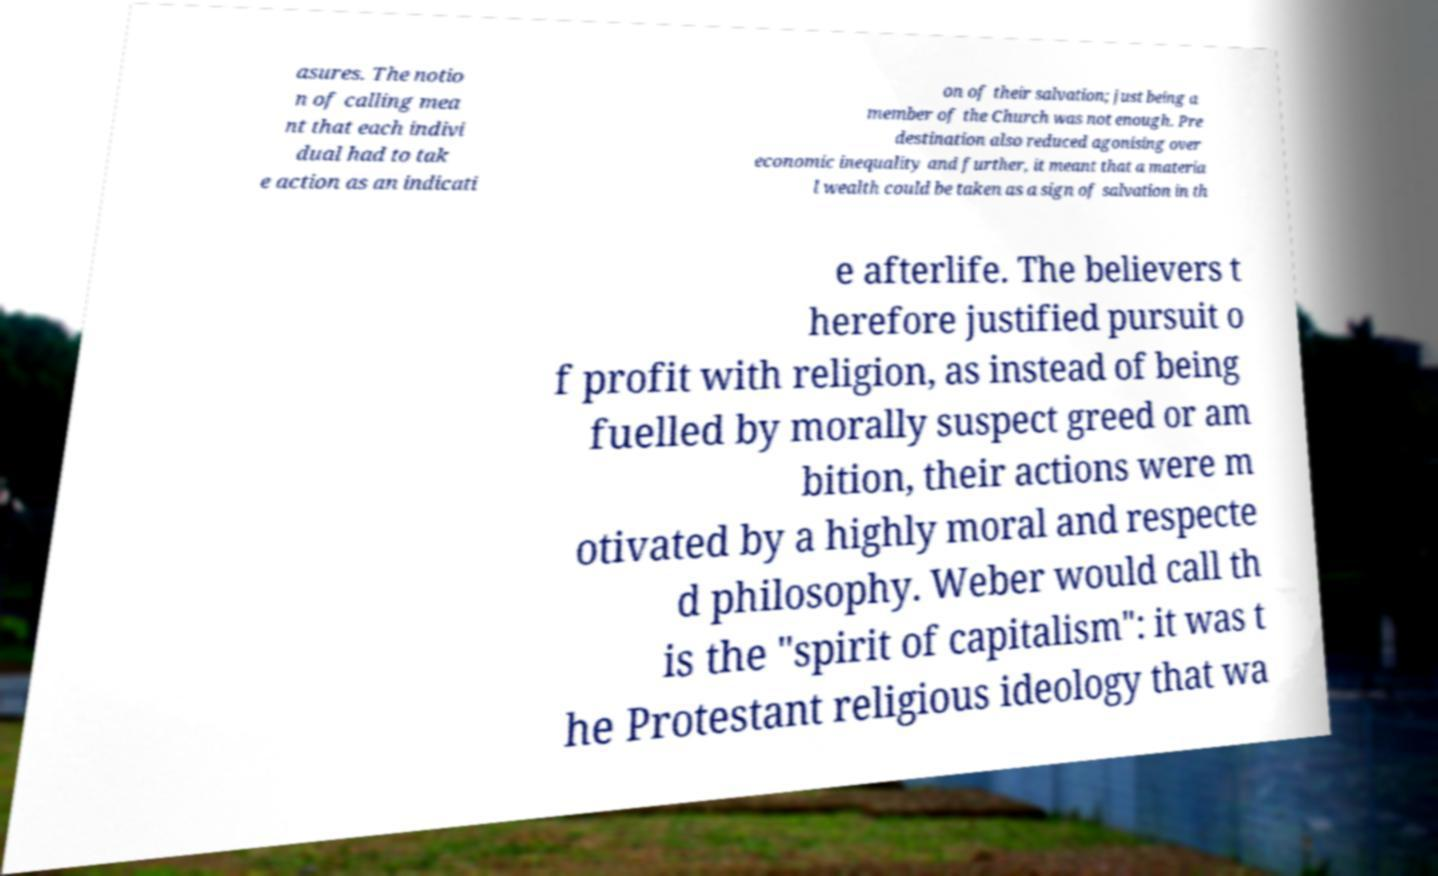Can you read and provide the text displayed in the image?This photo seems to have some interesting text. Can you extract and type it out for me? asures. The notio n of calling mea nt that each indivi dual had to tak e action as an indicati on of their salvation; just being a member of the Church was not enough. Pre destination also reduced agonising over economic inequality and further, it meant that a materia l wealth could be taken as a sign of salvation in th e afterlife. The believers t herefore justified pursuit o f profit with religion, as instead of being fuelled by morally suspect greed or am bition, their actions were m otivated by a highly moral and respecte d philosophy. Weber would call th is the "spirit of capitalism": it was t he Protestant religious ideology that wa 